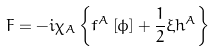Convert formula to latex. <formula><loc_0><loc_0><loc_500><loc_500>F = - i \chi _ { A } \left \{ f ^ { A } \left [ \phi \right ] + \frac { 1 } { 2 } \xi h ^ { A } \right \}</formula> 